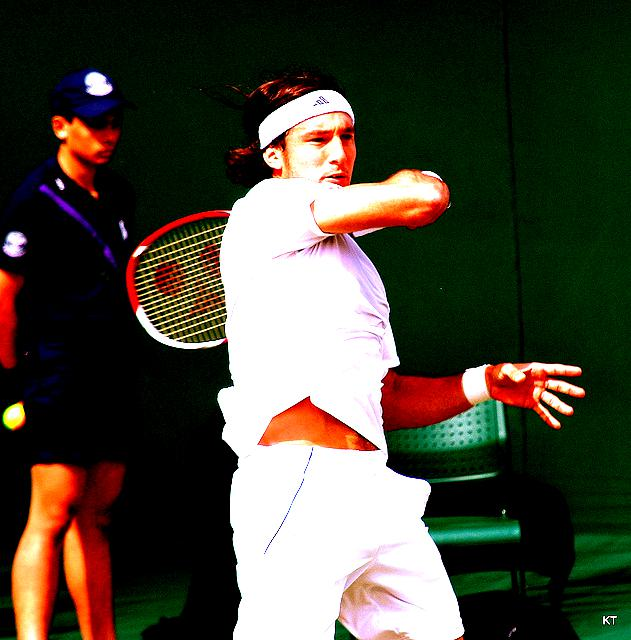What does the player's attire suggest about the event? The player's attire, consisting of a white sports shirt, wristband, and headband, suggests he is dressed for a competitive and possibly prestigious tennis event where athletes typically wear white, like at Wimbledon. Could you comment on the technique the player is using? Certainly, the tennis player is executing a single-handed backhand, a challenging stroke that requires precision and timing. His follow-through indicates a strong hit, and his stance reflects a high level of skill. 